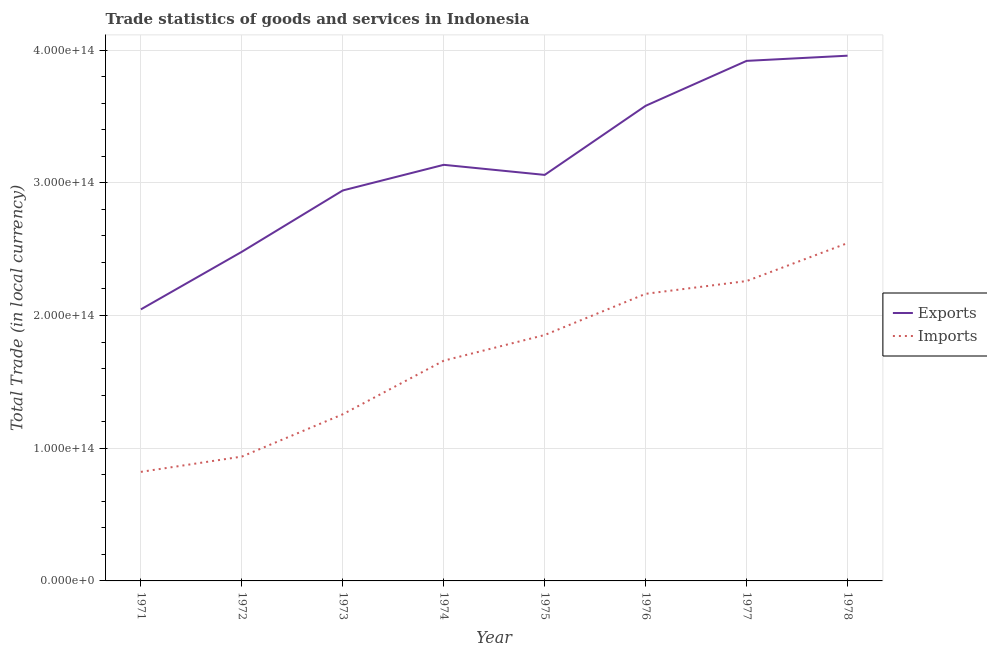How many different coloured lines are there?
Provide a succinct answer. 2. Is the number of lines equal to the number of legend labels?
Ensure brevity in your answer.  Yes. What is the imports of goods and services in 1971?
Your response must be concise. 8.22e+13. Across all years, what is the maximum imports of goods and services?
Offer a very short reply. 2.55e+14. Across all years, what is the minimum imports of goods and services?
Your answer should be very brief. 8.22e+13. In which year was the export of goods and services maximum?
Provide a short and direct response. 1978. In which year was the export of goods and services minimum?
Ensure brevity in your answer.  1971. What is the total export of goods and services in the graph?
Keep it short and to the point. 2.51e+15. What is the difference between the imports of goods and services in 1974 and that in 1975?
Make the answer very short. -1.93e+13. What is the difference between the imports of goods and services in 1971 and the export of goods and services in 1977?
Provide a short and direct response. -3.10e+14. What is the average imports of goods and services per year?
Ensure brevity in your answer.  1.69e+14. In the year 1975, what is the difference between the imports of goods and services and export of goods and services?
Provide a succinct answer. -1.21e+14. What is the ratio of the imports of goods and services in 1972 to that in 1977?
Make the answer very short. 0.41. What is the difference between the highest and the second highest export of goods and services?
Your answer should be very brief. 3.91e+12. What is the difference between the highest and the lowest export of goods and services?
Give a very brief answer. 1.91e+14. In how many years, is the export of goods and services greater than the average export of goods and services taken over all years?
Provide a succinct answer. 3. Is the sum of the export of goods and services in 1976 and 1977 greater than the maximum imports of goods and services across all years?
Your response must be concise. Yes. Does the export of goods and services monotonically increase over the years?
Offer a terse response. No. Is the export of goods and services strictly greater than the imports of goods and services over the years?
Provide a succinct answer. Yes. What is the difference between two consecutive major ticks on the Y-axis?
Make the answer very short. 1.00e+14. Does the graph contain any zero values?
Your answer should be compact. No. How many legend labels are there?
Ensure brevity in your answer.  2. What is the title of the graph?
Give a very brief answer. Trade statistics of goods and services in Indonesia. What is the label or title of the Y-axis?
Make the answer very short. Total Trade (in local currency). What is the Total Trade (in local currency) of Exports in 1971?
Give a very brief answer. 2.05e+14. What is the Total Trade (in local currency) in Imports in 1971?
Your response must be concise. 8.22e+13. What is the Total Trade (in local currency) in Exports in 1972?
Offer a very short reply. 2.48e+14. What is the Total Trade (in local currency) in Imports in 1972?
Provide a short and direct response. 9.37e+13. What is the Total Trade (in local currency) in Exports in 1973?
Provide a succinct answer. 2.94e+14. What is the Total Trade (in local currency) in Imports in 1973?
Ensure brevity in your answer.  1.26e+14. What is the Total Trade (in local currency) in Exports in 1974?
Provide a short and direct response. 3.14e+14. What is the Total Trade (in local currency) in Imports in 1974?
Provide a short and direct response. 1.66e+14. What is the Total Trade (in local currency) in Exports in 1975?
Offer a terse response. 3.06e+14. What is the Total Trade (in local currency) in Imports in 1975?
Ensure brevity in your answer.  1.85e+14. What is the Total Trade (in local currency) in Exports in 1976?
Your answer should be very brief. 3.58e+14. What is the Total Trade (in local currency) of Imports in 1976?
Make the answer very short. 2.16e+14. What is the Total Trade (in local currency) in Exports in 1977?
Offer a terse response. 3.92e+14. What is the Total Trade (in local currency) of Imports in 1977?
Make the answer very short. 2.26e+14. What is the Total Trade (in local currency) in Exports in 1978?
Your response must be concise. 3.96e+14. What is the Total Trade (in local currency) in Imports in 1978?
Your response must be concise. 2.55e+14. Across all years, what is the maximum Total Trade (in local currency) of Exports?
Offer a very short reply. 3.96e+14. Across all years, what is the maximum Total Trade (in local currency) in Imports?
Offer a very short reply. 2.55e+14. Across all years, what is the minimum Total Trade (in local currency) in Exports?
Offer a terse response. 2.05e+14. Across all years, what is the minimum Total Trade (in local currency) of Imports?
Your answer should be compact. 8.22e+13. What is the total Total Trade (in local currency) in Exports in the graph?
Provide a short and direct response. 2.51e+15. What is the total Total Trade (in local currency) of Imports in the graph?
Ensure brevity in your answer.  1.35e+15. What is the difference between the Total Trade (in local currency) of Exports in 1971 and that in 1972?
Make the answer very short. -4.34e+13. What is the difference between the Total Trade (in local currency) of Imports in 1971 and that in 1972?
Give a very brief answer. -1.15e+13. What is the difference between the Total Trade (in local currency) of Exports in 1971 and that in 1973?
Make the answer very short. -8.96e+13. What is the difference between the Total Trade (in local currency) in Imports in 1971 and that in 1973?
Your answer should be compact. -4.34e+13. What is the difference between the Total Trade (in local currency) of Exports in 1971 and that in 1974?
Provide a short and direct response. -1.09e+14. What is the difference between the Total Trade (in local currency) in Imports in 1971 and that in 1974?
Your answer should be very brief. -8.38e+13. What is the difference between the Total Trade (in local currency) in Exports in 1971 and that in 1975?
Offer a very short reply. -1.01e+14. What is the difference between the Total Trade (in local currency) of Imports in 1971 and that in 1975?
Make the answer very short. -1.03e+14. What is the difference between the Total Trade (in local currency) of Exports in 1971 and that in 1976?
Provide a succinct answer. -1.53e+14. What is the difference between the Total Trade (in local currency) in Imports in 1971 and that in 1976?
Your answer should be very brief. -1.34e+14. What is the difference between the Total Trade (in local currency) in Exports in 1971 and that in 1977?
Offer a terse response. -1.87e+14. What is the difference between the Total Trade (in local currency) of Imports in 1971 and that in 1977?
Your answer should be compact. -1.44e+14. What is the difference between the Total Trade (in local currency) of Exports in 1971 and that in 1978?
Make the answer very short. -1.91e+14. What is the difference between the Total Trade (in local currency) in Imports in 1971 and that in 1978?
Provide a short and direct response. -1.72e+14. What is the difference between the Total Trade (in local currency) of Exports in 1972 and that in 1973?
Your answer should be very brief. -4.62e+13. What is the difference between the Total Trade (in local currency) of Imports in 1972 and that in 1973?
Offer a very short reply. -3.19e+13. What is the difference between the Total Trade (in local currency) in Exports in 1972 and that in 1974?
Offer a terse response. -6.55e+13. What is the difference between the Total Trade (in local currency) in Imports in 1972 and that in 1974?
Make the answer very short. -7.23e+13. What is the difference between the Total Trade (in local currency) of Exports in 1972 and that in 1975?
Offer a terse response. -5.79e+13. What is the difference between the Total Trade (in local currency) of Imports in 1972 and that in 1975?
Ensure brevity in your answer.  -9.16e+13. What is the difference between the Total Trade (in local currency) in Exports in 1972 and that in 1976?
Give a very brief answer. -1.10e+14. What is the difference between the Total Trade (in local currency) in Imports in 1972 and that in 1976?
Offer a very short reply. -1.23e+14. What is the difference between the Total Trade (in local currency) in Exports in 1972 and that in 1977?
Provide a succinct answer. -1.44e+14. What is the difference between the Total Trade (in local currency) of Imports in 1972 and that in 1977?
Make the answer very short. -1.32e+14. What is the difference between the Total Trade (in local currency) in Exports in 1972 and that in 1978?
Provide a short and direct response. -1.48e+14. What is the difference between the Total Trade (in local currency) in Imports in 1972 and that in 1978?
Give a very brief answer. -1.61e+14. What is the difference between the Total Trade (in local currency) of Exports in 1973 and that in 1974?
Ensure brevity in your answer.  -1.93e+13. What is the difference between the Total Trade (in local currency) in Imports in 1973 and that in 1974?
Your response must be concise. -4.04e+13. What is the difference between the Total Trade (in local currency) in Exports in 1973 and that in 1975?
Provide a succinct answer. -1.17e+13. What is the difference between the Total Trade (in local currency) of Imports in 1973 and that in 1975?
Provide a succinct answer. -5.97e+13. What is the difference between the Total Trade (in local currency) in Exports in 1973 and that in 1976?
Ensure brevity in your answer.  -6.38e+13. What is the difference between the Total Trade (in local currency) in Imports in 1973 and that in 1976?
Give a very brief answer. -9.08e+13. What is the difference between the Total Trade (in local currency) in Exports in 1973 and that in 1977?
Offer a terse response. -9.76e+13. What is the difference between the Total Trade (in local currency) in Imports in 1973 and that in 1977?
Give a very brief answer. -1.00e+14. What is the difference between the Total Trade (in local currency) of Exports in 1973 and that in 1978?
Your answer should be compact. -1.02e+14. What is the difference between the Total Trade (in local currency) of Imports in 1973 and that in 1978?
Offer a terse response. -1.29e+14. What is the difference between the Total Trade (in local currency) of Exports in 1974 and that in 1975?
Ensure brevity in your answer.  7.60e+12. What is the difference between the Total Trade (in local currency) of Imports in 1974 and that in 1975?
Give a very brief answer. -1.93e+13. What is the difference between the Total Trade (in local currency) of Exports in 1974 and that in 1976?
Your answer should be compact. -4.45e+13. What is the difference between the Total Trade (in local currency) of Imports in 1974 and that in 1976?
Provide a short and direct response. -5.04e+13. What is the difference between the Total Trade (in local currency) of Exports in 1974 and that in 1977?
Ensure brevity in your answer.  -7.83e+13. What is the difference between the Total Trade (in local currency) in Imports in 1974 and that in 1977?
Give a very brief answer. -6.00e+13. What is the difference between the Total Trade (in local currency) in Exports in 1974 and that in 1978?
Your answer should be very brief. -8.22e+13. What is the difference between the Total Trade (in local currency) in Imports in 1974 and that in 1978?
Provide a succinct answer. -8.86e+13. What is the difference between the Total Trade (in local currency) in Exports in 1975 and that in 1976?
Your response must be concise. -5.21e+13. What is the difference between the Total Trade (in local currency) in Imports in 1975 and that in 1976?
Make the answer very short. -3.10e+13. What is the difference between the Total Trade (in local currency) of Exports in 1975 and that in 1977?
Offer a terse response. -8.59e+13. What is the difference between the Total Trade (in local currency) in Imports in 1975 and that in 1977?
Your answer should be compact. -4.07e+13. What is the difference between the Total Trade (in local currency) of Exports in 1975 and that in 1978?
Offer a very short reply. -8.98e+13. What is the difference between the Total Trade (in local currency) of Imports in 1975 and that in 1978?
Offer a very short reply. -6.93e+13. What is the difference between the Total Trade (in local currency) in Exports in 1976 and that in 1977?
Give a very brief answer. -3.39e+13. What is the difference between the Total Trade (in local currency) in Imports in 1976 and that in 1977?
Provide a short and direct response. -9.62e+12. What is the difference between the Total Trade (in local currency) of Exports in 1976 and that in 1978?
Your answer should be very brief. -3.78e+13. What is the difference between the Total Trade (in local currency) in Imports in 1976 and that in 1978?
Make the answer very short. -3.82e+13. What is the difference between the Total Trade (in local currency) in Exports in 1977 and that in 1978?
Your answer should be compact. -3.91e+12. What is the difference between the Total Trade (in local currency) in Imports in 1977 and that in 1978?
Provide a short and direct response. -2.86e+13. What is the difference between the Total Trade (in local currency) of Exports in 1971 and the Total Trade (in local currency) of Imports in 1972?
Give a very brief answer. 1.11e+14. What is the difference between the Total Trade (in local currency) of Exports in 1971 and the Total Trade (in local currency) of Imports in 1973?
Offer a very short reply. 7.90e+13. What is the difference between the Total Trade (in local currency) in Exports in 1971 and the Total Trade (in local currency) in Imports in 1974?
Make the answer very short. 3.87e+13. What is the difference between the Total Trade (in local currency) of Exports in 1971 and the Total Trade (in local currency) of Imports in 1975?
Your answer should be compact. 1.93e+13. What is the difference between the Total Trade (in local currency) of Exports in 1971 and the Total Trade (in local currency) of Imports in 1976?
Ensure brevity in your answer.  -1.17e+13. What is the difference between the Total Trade (in local currency) of Exports in 1971 and the Total Trade (in local currency) of Imports in 1977?
Your answer should be compact. -2.14e+13. What is the difference between the Total Trade (in local currency) of Exports in 1971 and the Total Trade (in local currency) of Imports in 1978?
Provide a short and direct response. -4.99e+13. What is the difference between the Total Trade (in local currency) in Exports in 1972 and the Total Trade (in local currency) in Imports in 1973?
Give a very brief answer. 1.22e+14. What is the difference between the Total Trade (in local currency) of Exports in 1972 and the Total Trade (in local currency) of Imports in 1974?
Offer a very short reply. 8.21e+13. What is the difference between the Total Trade (in local currency) of Exports in 1972 and the Total Trade (in local currency) of Imports in 1975?
Provide a succinct answer. 6.27e+13. What is the difference between the Total Trade (in local currency) of Exports in 1972 and the Total Trade (in local currency) of Imports in 1976?
Give a very brief answer. 3.17e+13. What is the difference between the Total Trade (in local currency) in Exports in 1972 and the Total Trade (in local currency) in Imports in 1977?
Provide a short and direct response. 2.20e+13. What is the difference between the Total Trade (in local currency) of Exports in 1972 and the Total Trade (in local currency) of Imports in 1978?
Offer a very short reply. -6.54e+12. What is the difference between the Total Trade (in local currency) of Exports in 1973 and the Total Trade (in local currency) of Imports in 1974?
Give a very brief answer. 1.28e+14. What is the difference between the Total Trade (in local currency) of Exports in 1973 and the Total Trade (in local currency) of Imports in 1975?
Keep it short and to the point. 1.09e+14. What is the difference between the Total Trade (in local currency) of Exports in 1973 and the Total Trade (in local currency) of Imports in 1976?
Your answer should be very brief. 7.79e+13. What is the difference between the Total Trade (in local currency) of Exports in 1973 and the Total Trade (in local currency) of Imports in 1977?
Provide a succinct answer. 6.83e+13. What is the difference between the Total Trade (in local currency) in Exports in 1973 and the Total Trade (in local currency) in Imports in 1978?
Ensure brevity in your answer.  3.97e+13. What is the difference between the Total Trade (in local currency) in Exports in 1974 and the Total Trade (in local currency) in Imports in 1975?
Provide a short and direct response. 1.28e+14. What is the difference between the Total Trade (in local currency) in Exports in 1974 and the Total Trade (in local currency) in Imports in 1976?
Keep it short and to the point. 9.72e+13. What is the difference between the Total Trade (in local currency) in Exports in 1974 and the Total Trade (in local currency) in Imports in 1977?
Offer a very short reply. 8.76e+13. What is the difference between the Total Trade (in local currency) of Exports in 1974 and the Total Trade (in local currency) of Imports in 1978?
Offer a very short reply. 5.90e+13. What is the difference between the Total Trade (in local currency) in Exports in 1975 and the Total Trade (in local currency) in Imports in 1976?
Offer a very short reply. 8.96e+13. What is the difference between the Total Trade (in local currency) of Exports in 1975 and the Total Trade (in local currency) of Imports in 1977?
Your answer should be very brief. 8.00e+13. What is the difference between the Total Trade (in local currency) in Exports in 1975 and the Total Trade (in local currency) in Imports in 1978?
Make the answer very short. 5.14e+13. What is the difference between the Total Trade (in local currency) of Exports in 1976 and the Total Trade (in local currency) of Imports in 1977?
Offer a terse response. 1.32e+14. What is the difference between the Total Trade (in local currency) of Exports in 1976 and the Total Trade (in local currency) of Imports in 1978?
Ensure brevity in your answer.  1.03e+14. What is the difference between the Total Trade (in local currency) of Exports in 1977 and the Total Trade (in local currency) of Imports in 1978?
Provide a succinct answer. 1.37e+14. What is the average Total Trade (in local currency) of Exports per year?
Make the answer very short. 3.14e+14. What is the average Total Trade (in local currency) in Imports per year?
Offer a terse response. 1.69e+14. In the year 1971, what is the difference between the Total Trade (in local currency) in Exports and Total Trade (in local currency) in Imports?
Ensure brevity in your answer.  1.22e+14. In the year 1972, what is the difference between the Total Trade (in local currency) of Exports and Total Trade (in local currency) of Imports?
Offer a very short reply. 1.54e+14. In the year 1973, what is the difference between the Total Trade (in local currency) in Exports and Total Trade (in local currency) in Imports?
Keep it short and to the point. 1.69e+14. In the year 1974, what is the difference between the Total Trade (in local currency) of Exports and Total Trade (in local currency) of Imports?
Your response must be concise. 1.48e+14. In the year 1975, what is the difference between the Total Trade (in local currency) in Exports and Total Trade (in local currency) in Imports?
Give a very brief answer. 1.21e+14. In the year 1976, what is the difference between the Total Trade (in local currency) of Exports and Total Trade (in local currency) of Imports?
Give a very brief answer. 1.42e+14. In the year 1977, what is the difference between the Total Trade (in local currency) of Exports and Total Trade (in local currency) of Imports?
Offer a very short reply. 1.66e+14. In the year 1978, what is the difference between the Total Trade (in local currency) of Exports and Total Trade (in local currency) of Imports?
Offer a terse response. 1.41e+14. What is the ratio of the Total Trade (in local currency) of Exports in 1971 to that in 1972?
Ensure brevity in your answer.  0.82. What is the ratio of the Total Trade (in local currency) in Imports in 1971 to that in 1972?
Give a very brief answer. 0.88. What is the ratio of the Total Trade (in local currency) of Exports in 1971 to that in 1973?
Your answer should be very brief. 0.7. What is the ratio of the Total Trade (in local currency) of Imports in 1971 to that in 1973?
Offer a terse response. 0.65. What is the ratio of the Total Trade (in local currency) in Exports in 1971 to that in 1974?
Your response must be concise. 0.65. What is the ratio of the Total Trade (in local currency) of Imports in 1971 to that in 1974?
Ensure brevity in your answer.  0.5. What is the ratio of the Total Trade (in local currency) in Exports in 1971 to that in 1975?
Your response must be concise. 0.67. What is the ratio of the Total Trade (in local currency) of Imports in 1971 to that in 1975?
Your answer should be very brief. 0.44. What is the ratio of the Total Trade (in local currency) of Exports in 1971 to that in 1976?
Provide a succinct answer. 0.57. What is the ratio of the Total Trade (in local currency) of Imports in 1971 to that in 1976?
Offer a terse response. 0.38. What is the ratio of the Total Trade (in local currency) in Exports in 1971 to that in 1977?
Provide a short and direct response. 0.52. What is the ratio of the Total Trade (in local currency) of Imports in 1971 to that in 1977?
Provide a short and direct response. 0.36. What is the ratio of the Total Trade (in local currency) in Exports in 1971 to that in 1978?
Your answer should be compact. 0.52. What is the ratio of the Total Trade (in local currency) of Imports in 1971 to that in 1978?
Keep it short and to the point. 0.32. What is the ratio of the Total Trade (in local currency) in Exports in 1972 to that in 1973?
Offer a very short reply. 0.84. What is the ratio of the Total Trade (in local currency) in Imports in 1972 to that in 1973?
Your answer should be very brief. 0.75. What is the ratio of the Total Trade (in local currency) of Exports in 1972 to that in 1974?
Your response must be concise. 0.79. What is the ratio of the Total Trade (in local currency) of Imports in 1972 to that in 1974?
Ensure brevity in your answer.  0.56. What is the ratio of the Total Trade (in local currency) in Exports in 1972 to that in 1975?
Your response must be concise. 0.81. What is the ratio of the Total Trade (in local currency) of Imports in 1972 to that in 1975?
Provide a succinct answer. 0.51. What is the ratio of the Total Trade (in local currency) in Exports in 1972 to that in 1976?
Provide a short and direct response. 0.69. What is the ratio of the Total Trade (in local currency) in Imports in 1972 to that in 1976?
Offer a terse response. 0.43. What is the ratio of the Total Trade (in local currency) of Exports in 1972 to that in 1977?
Give a very brief answer. 0.63. What is the ratio of the Total Trade (in local currency) of Imports in 1972 to that in 1977?
Offer a terse response. 0.41. What is the ratio of the Total Trade (in local currency) in Exports in 1972 to that in 1978?
Your answer should be very brief. 0.63. What is the ratio of the Total Trade (in local currency) in Imports in 1972 to that in 1978?
Provide a succinct answer. 0.37. What is the ratio of the Total Trade (in local currency) in Exports in 1973 to that in 1974?
Provide a succinct answer. 0.94. What is the ratio of the Total Trade (in local currency) in Imports in 1973 to that in 1974?
Offer a terse response. 0.76. What is the ratio of the Total Trade (in local currency) in Exports in 1973 to that in 1975?
Your answer should be compact. 0.96. What is the ratio of the Total Trade (in local currency) in Imports in 1973 to that in 1975?
Make the answer very short. 0.68. What is the ratio of the Total Trade (in local currency) of Exports in 1973 to that in 1976?
Ensure brevity in your answer.  0.82. What is the ratio of the Total Trade (in local currency) of Imports in 1973 to that in 1976?
Your response must be concise. 0.58. What is the ratio of the Total Trade (in local currency) in Exports in 1973 to that in 1977?
Keep it short and to the point. 0.75. What is the ratio of the Total Trade (in local currency) of Imports in 1973 to that in 1977?
Provide a succinct answer. 0.56. What is the ratio of the Total Trade (in local currency) of Exports in 1973 to that in 1978?
Give a very brief answer. 0.74. What is the ratio of the Total Trade (in local currency) of Imports in 1973 to that in 1978?
Your answer should be compact. 0.49. What is the ratio of the Total Trade (in local currency) in Exports in 1974 to that in 1975?
Your answer should be very brief. 1.02. What is the ratio of the Total Trade (in local currency) of Imports in 1974 to that in 1975?
Offer a very short reply. 0.9. What is the ratio of the Total Trade (in local currency) in Exports in 1974 to that in 1976?
Your answer should be very brief. 0.88. What is the ratio of the Total Trade (in local currency) of Imports in 1974 to that in 1976?
Your response must be concise. 0.77. What is the ratio of the Total Trade (in local currency) in Exports in 1974 to that in 1977?
Your answer should be very brief. 0.8. What is the ratio of the Total Trade (in local currency) of Imports in 1974 to that in 1977?
Your answer should be compact. 0.73. What is the ratio of the Total Trade (in local currency) of Exports in 1974 to that in 1978?
Your answer should be compact. 0.79. What is the ratio of the Total Trade (in local currency) of Imports in 1974 to that in 1978?
Provide a succinct answer. 0.65. What is the ratio of the Total Trade (in local currency) of Exports in 1975 to that in 1976?
Give a very brief answer. 0.85. What is the ratio of the Total Trade (in local currency) of Imports in 1975 to that in 1976?
Provide a short and direct response. 0.86. What is the ratio of the Total Trade (in local currency) of Exports in 1975 to that in 1977?
Your response must be concise. 0.78. What is the ratio of the Total Trade (in local currency) of Imports in 1975 to that in 1977?
Offer a terse response. 0.82. What is the ratio of the Total Trade (in local currency) in Exports in 1975 to that in 1978?
Your answer should be very brief. 0.77. What is the ratio of the Total Trade (in local currency) of Imports in 1975 to that in 1978?
Your answer should be very brief. 0.73. What is the ratio of the Total Trade (in local currency) in Exports in 1976 to that in 1977?
Provide a succinct answer. 0.91. What is the ratio of the Total Trade (in local currency) in Imports in 1976 to that in 1977?
Offer a very short reply. 0.96. What is the ratio of the Total Trade (in local currency) of Exports in 1976 to that in 1978?
Provide a short and direct response. 0.9. What is the ratio of the Total Trade (in local currency) of Imports in 1976 to that in 1978?
Provide a succinct answer. 0.85. What is the ratio of the Total Trade (in local currency) of Imports in 1977 to that in 1978?
Your response must be concise. 0.89. What is the difference between the highest and the second highest Total Trade (in local currency) of Exports?
Keep it short and to the point. 3.91e+12. What is the difference between the highest and the second highest Total Trade (in local currency) of Imports?
Your answer should be compact. 2.86e+13. What is the difference between the highest and the lowest Total Trade (in local currency) of Exports?
Offer a very short reply. 1.91e+14. What is the difference between the highest and the lowest Total Trade (in local currency) of Imports?
Offer a terse response. 1.72e+14. 